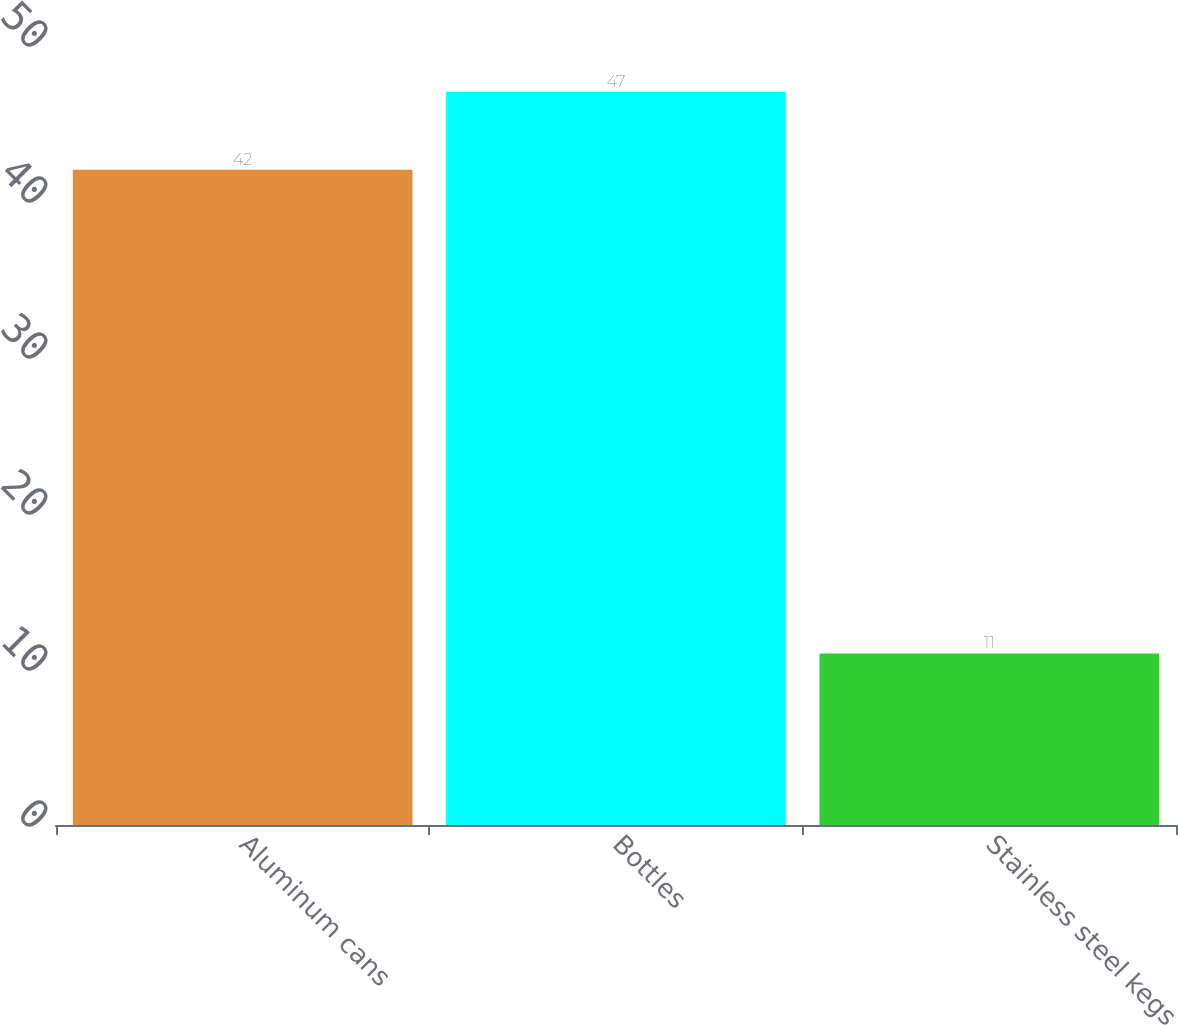<chart> <loc_0><loc_0><loc_500><loc_500><bar_chart><fcel>Aluminum cans<fcel>Bottles<fcel>Stainless steel kegs<nl><fcel>42<fcel>47<fcel>11<nl></chart> 